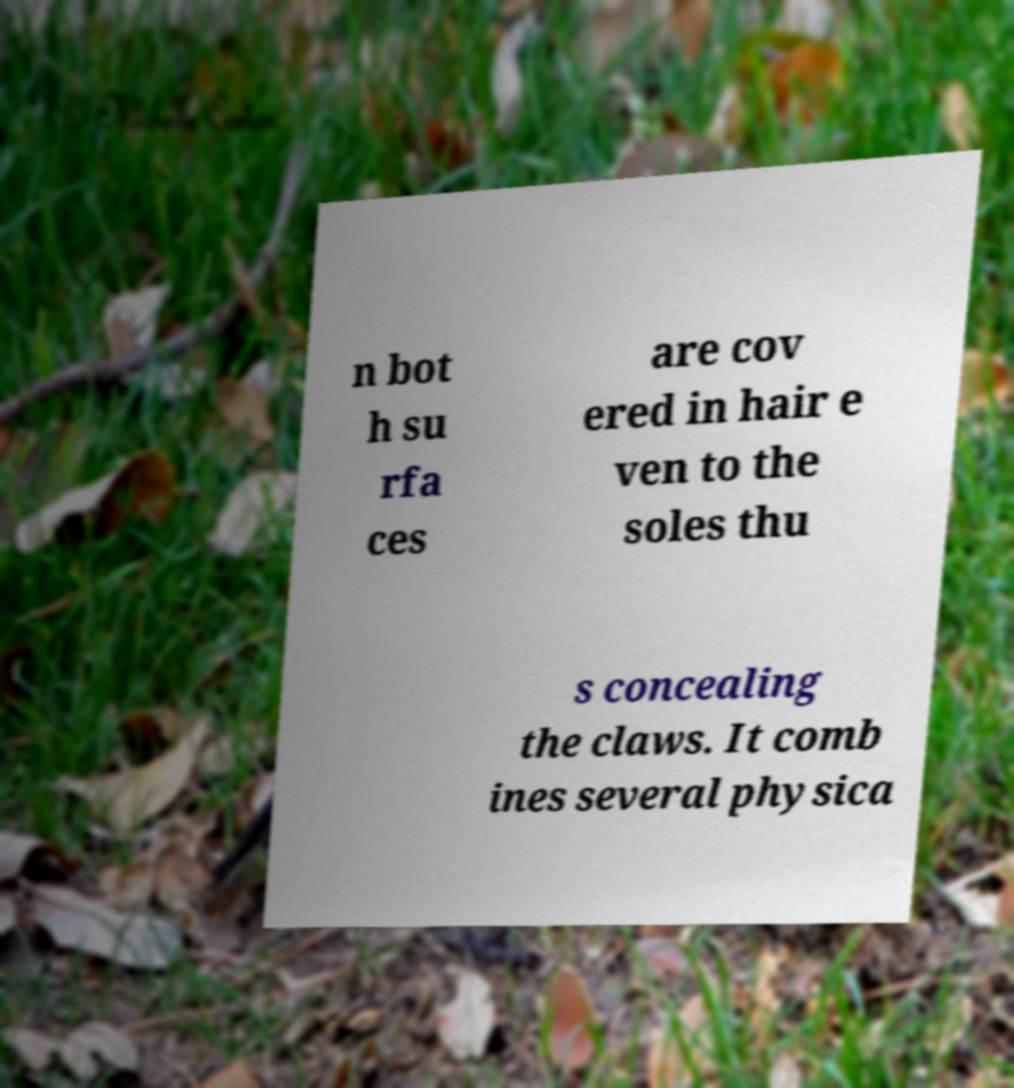Can you read and provide the text displayed in the image?This photo seems to have some interesting text. Can you extract and type it out for me? n bot h su rfa ces are cov ered in hair e ven to the soles thu s concealing the claws. It comb ines several physica 